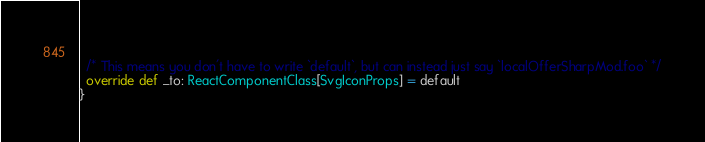<code> <loc_0><loc_0><loc_500><loc_500><_Scala_>  
  /* This means you don't have to write `default`, but can instead just say `localOfferSharpMod.foo` */
  override def _to: ReactComponentClass[SvgIconProps] = default
}
</code> 